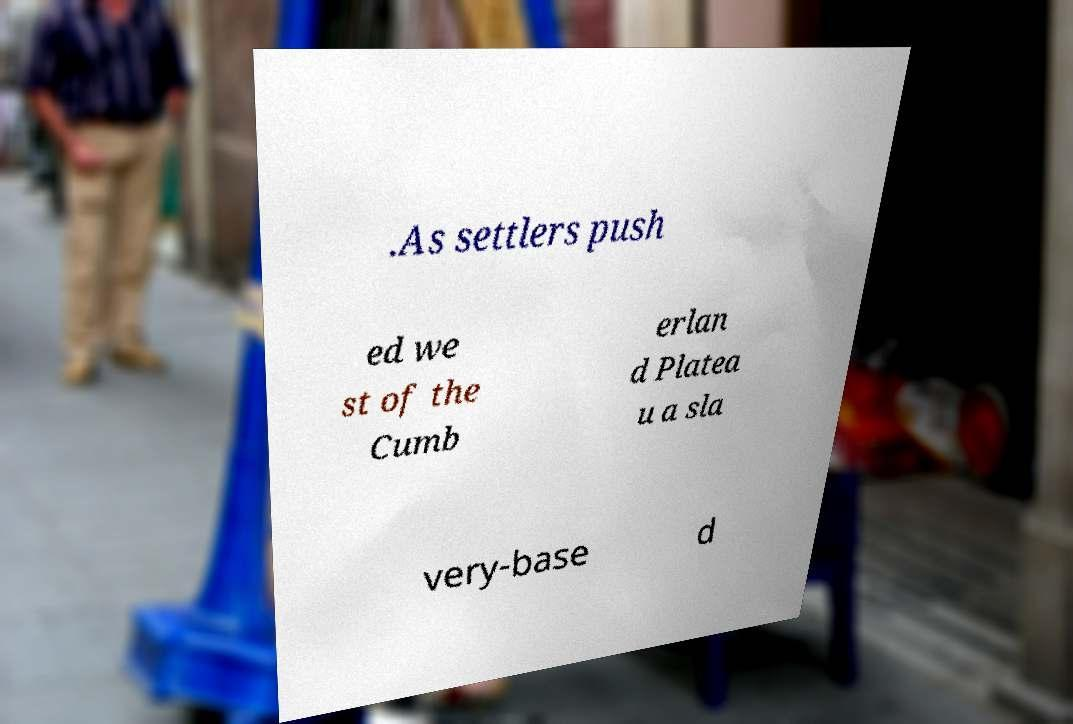Please read and relay the text visible in this image. What does it say? .As settlers push ed we st of the Cumb erlan d Platea u a sla very-base d 